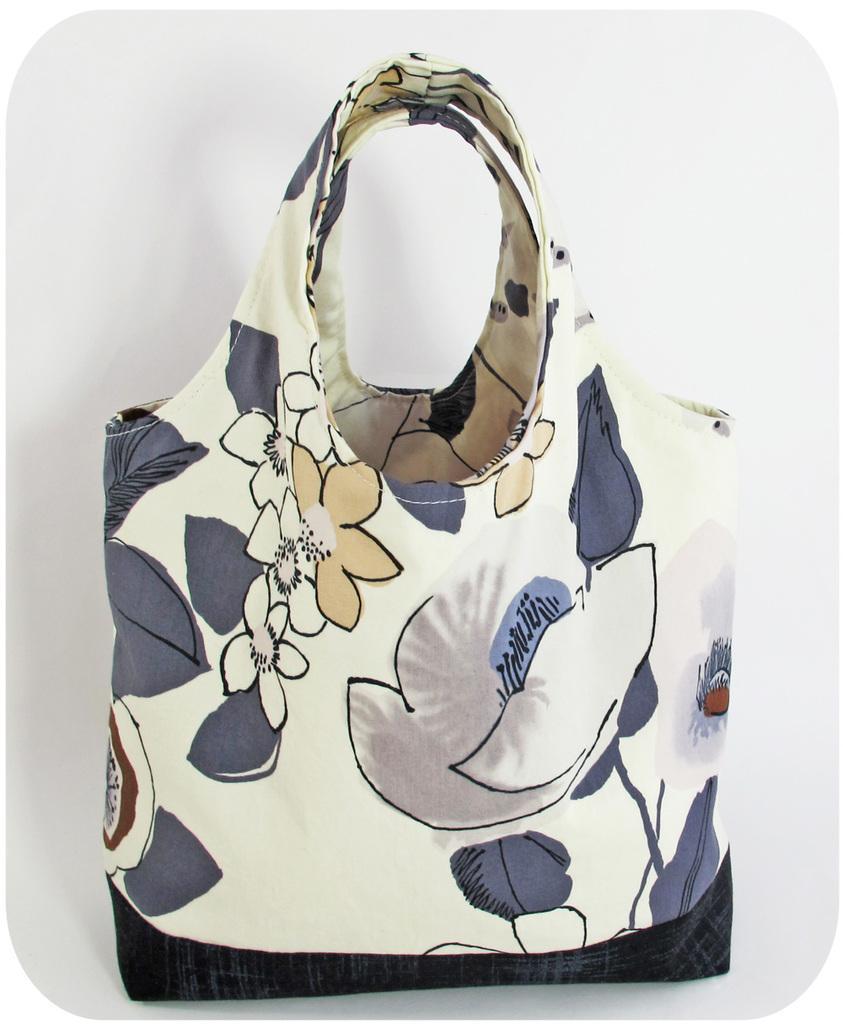In one or two sentences, can you explain what this image depicts? This picture describes about a bag. 